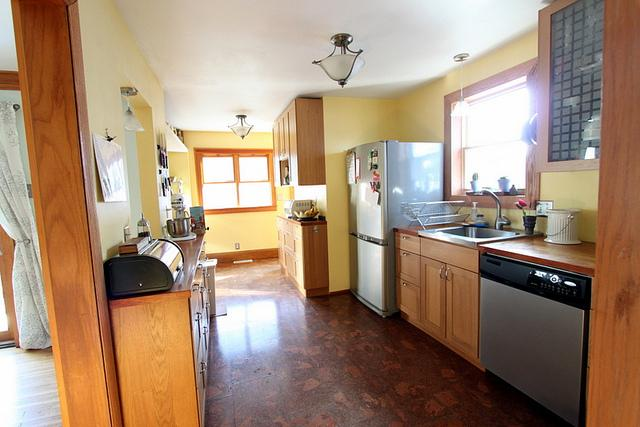What is the rolltop object used for?

Choices:
A) hold coffee
B) hold flour
C) bread box
D) paying bills bread box 